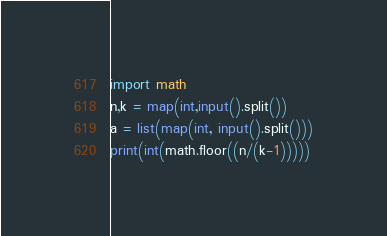<code> <loc_0><loc_0><loc_500><loc_500><_Python_>import math
n,k = map(int,input().split())
a = list(map(int, input().split()))
print(int(math.floor((n/(k-1)))))</code> 